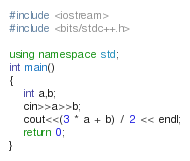<code> <loc_0><loc_0><loc_500><loc_500><_C++_>#include <iostream>
#include <bits/stdc++.h>

using namespace std;
int main()
{
    int a,b;
    cin>>a>>b;
    cout<<(3 * a + b) / 2 << endl;
    return 0;
}</code> 